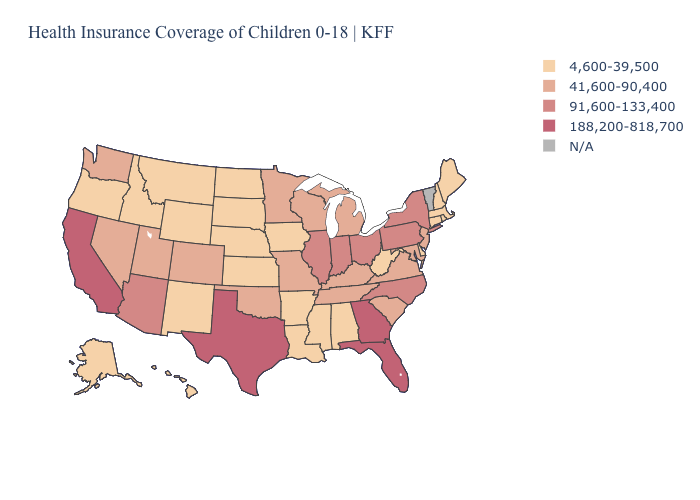Does the map have missing data?
Be succinct. Yes. What is the highest value in the USA?
Quick response, please. 188,200-818,700. Name the states that have a value in the range 41,600-90,400?
Answer briefly. Colorado, Kentucky, Maryland, Michigan, Minnesota, Missouri, Nevada, New Jersey, Oklahoma, South Carolina, Tennessee, Utah, Virginia, Washington, Wisconsin. Among the states that border New York , does Massachusetts have the highest value?
Quick response, please. No. What is the value of Tennessee?
Be succinct. 41,600-90,400. What is the value of Oklahoma?
Concise answer only. 41,600-90,400. What is the lowest value in states that border Michigan?
Write a very short answer. 41,600-90,400. What is the value of Maine?
Quick response, please. 4,600-39,500. Does Nevada have the lowest value in the USA?
Write a very short answer. No. Among the states that border California , does Arizona have the lowest value?
Concise answer only. No. Name the states that have a value in the range N/A?
Quick response, please. Vermont. Name the states that have a value in the range N/A?
Answer briefly. Vermont. 